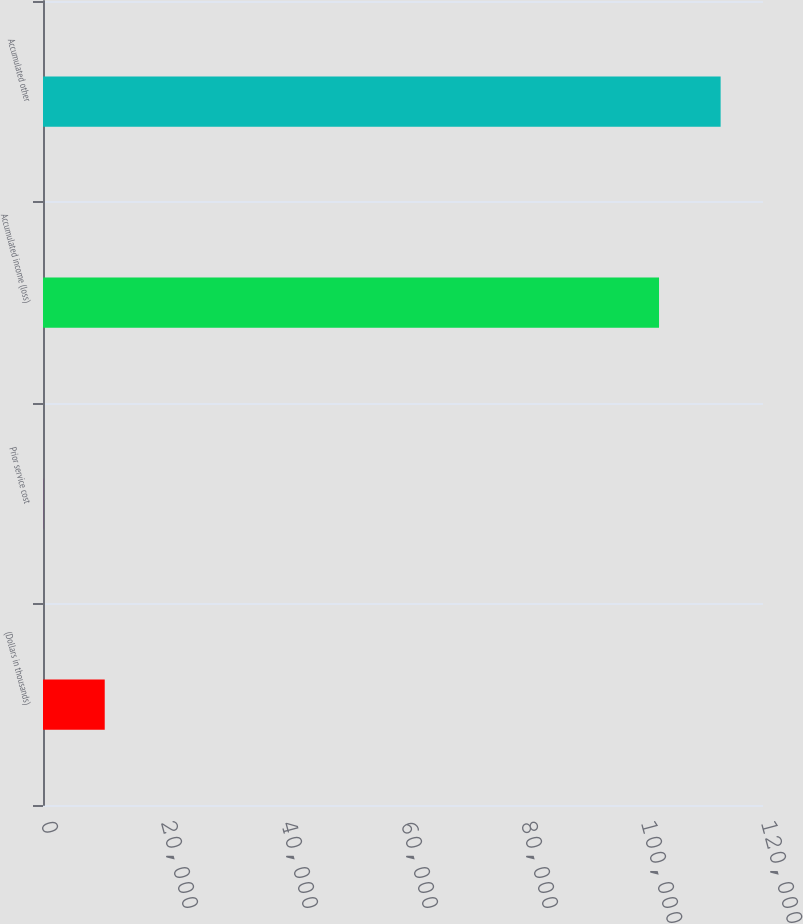Convert chart. <chart><loc_0><loc_0><loc_500><loc_500><bar_chart><fcel>(Dollars in thousands)<fcel>Prior service cost<fcel>Accumulated income (loss)<fcel>Accumulated other<nl><fcel>10288.1<fcel>21<fcel>102671<fcel>112938<nl></chart> 